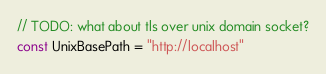<code> <loc_0><loc_0><loc_500><loc_500><_Go_>// TODO: what about tls over unix domain socket?
const UnixBasePath = "http://localhost"
</code> 